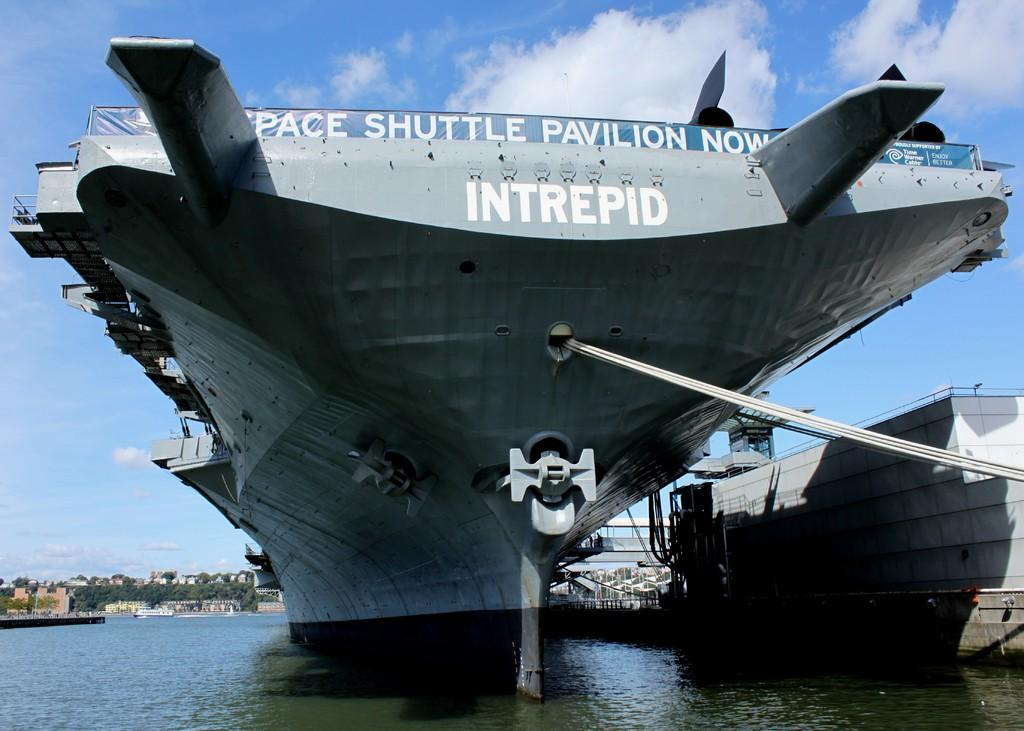<image>
Present a compact description of the photo's key features. A large ship with writing on the end that says INTREPID. 